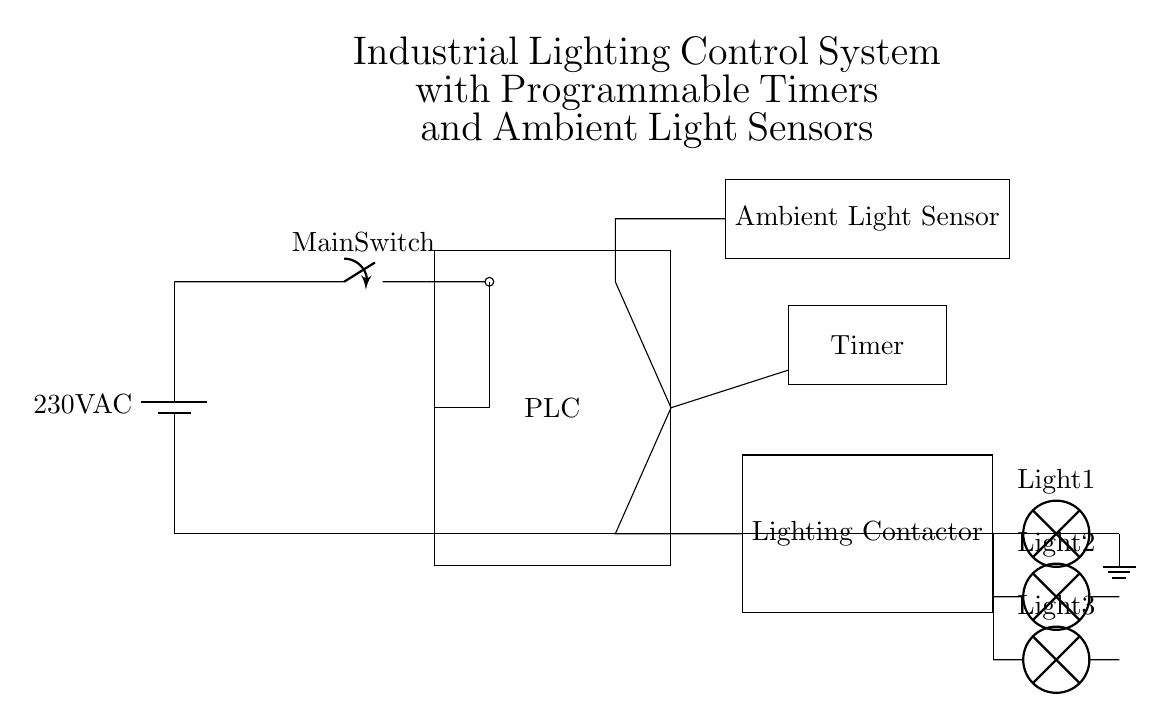What is the main voltage supplied to the circuit? The schematic indicates a battery supplying a voltage of 230V AC, which is the main power supply connected to the circuit's main components.
Answer: 230V AC What component is responsible for controlling the operation of the lighting based on ambient conditions? The component that responds to ambient light levels and influences the circuit operation is the Ambient Light Sensor, which is positioned to affect the PLC's operations based on light input.
Answer: Ambient Light Sensor How many lights are connected to the lighting contactor? The circuit shows three distinct lamps labeled Light 1, Light 2, and Light 3, all connected to the lighting contactor, indicating that these are the lights controlled by the contactor.
Answer: Three What is the function of the programmable logic controller (PLC) in this circuit? The PLC processes inputs from the Ambient Light Sensor and Timer to control the output to the lighting contactor, managing when the lights should turn on or off automatically.
Answer: Control Which component allows manual operation of the lighting system? The Main Switch is the component that allows for manual control of the entire lighting system, positioned before the PLC and thus controlling the power supply to it.
Answer: Main Switch Which device holds the function of turning the lights on and off indirectly? The Lighting Contactor serves as the device that indirectly controls the on/off state of the lights, based on the signals it receives from the PLC, thus acting as a relay for the lights.
Answer: Lighting Contactor 